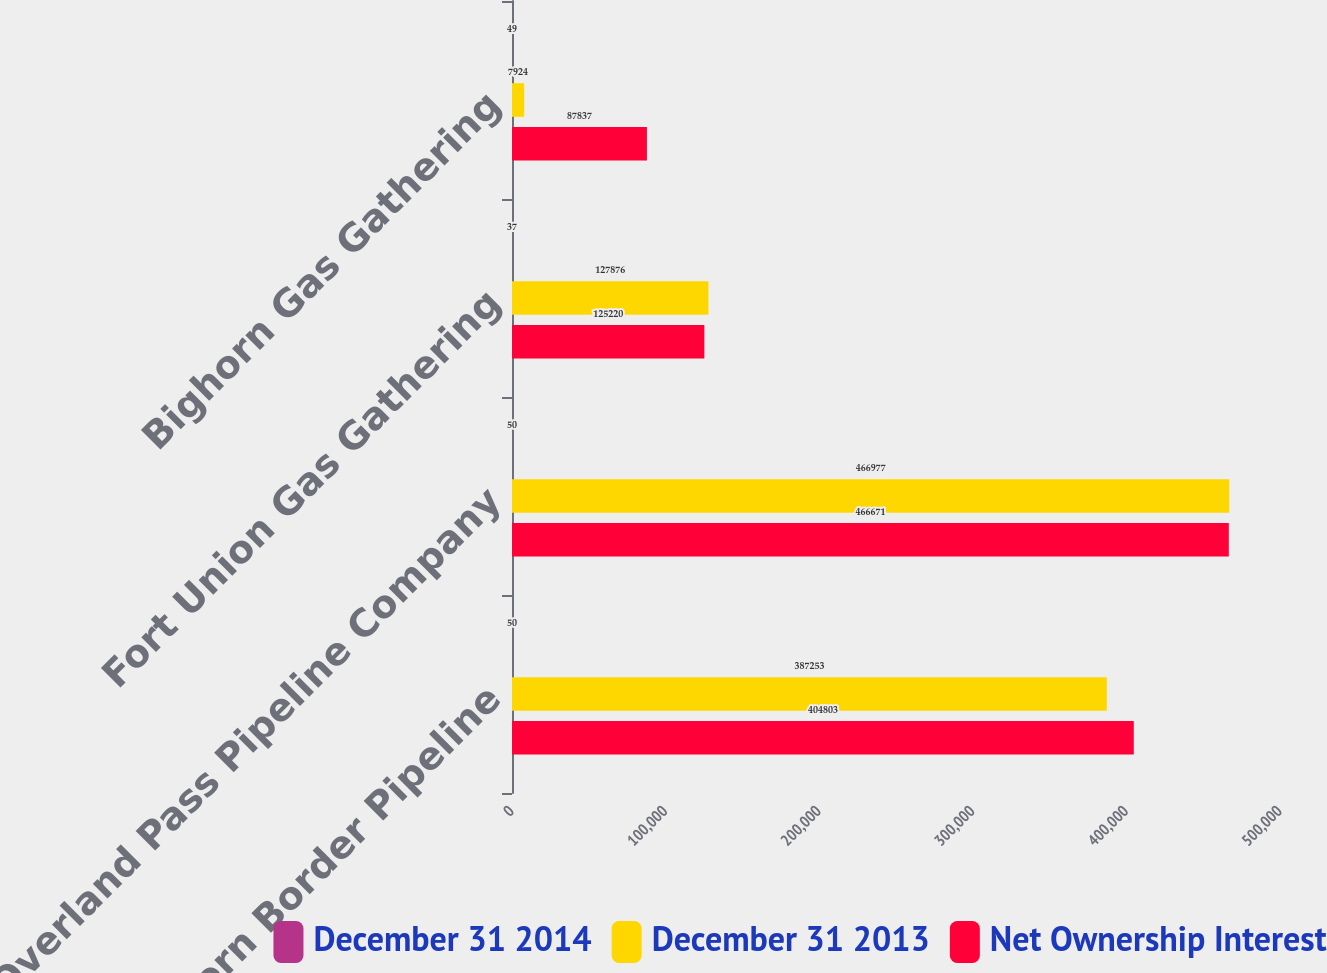Convert chart to OTSL. <chart><loc_0><loc_0><loc_500><loc_500><stacked_bar_chart><ecel><fcel>Northern Border Pipeline<fcel>Overland Pass Pipeline Company<fcel>Fort Union Gas Gathering<fcel>Bighorn Gas Gathering<nl><fcel>December 31 2014<fcel>50<fcel>50<fcel>37<fcel>49<nl><fcel>December 31 2013<fcel>387253<fcel>466977<fcel>127876<fcel>7924<nl><fcel>Net Ownership Interest<fcel>404803<fcel>466671<fcel>125220<fcel>87837<nl></chart> 